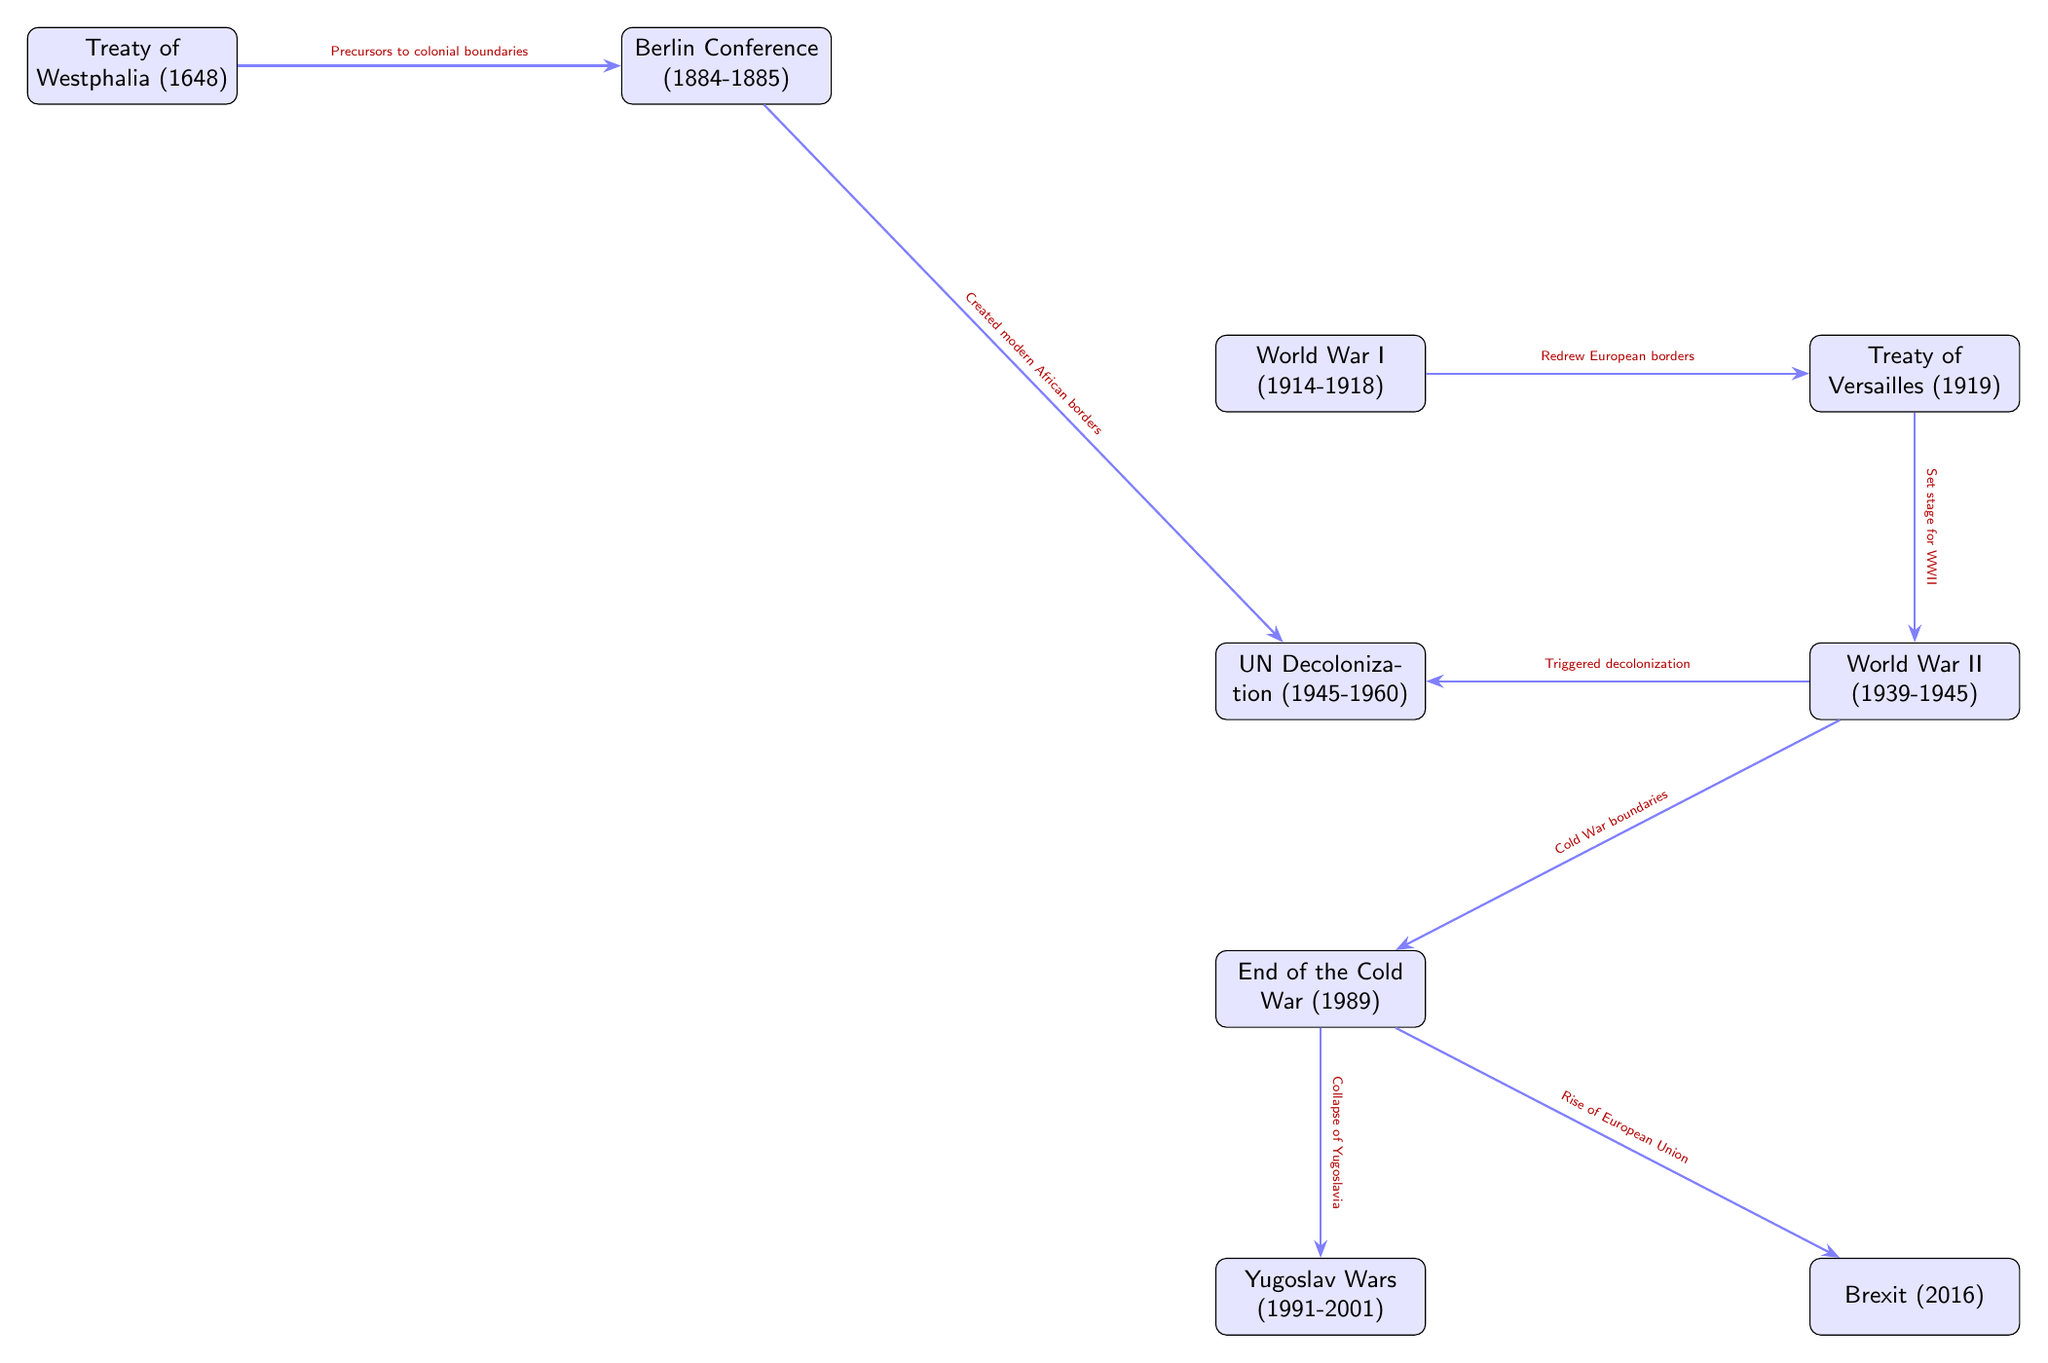What historical event is linked to the creation of modern African borders? The diagram shows an arrow from the Berlin Conference to UN Decolonization, indicating that the Berlin Conference is responsible for the creation of modern African borders.
Answer: Berlin Conference How many events are depicted in the diagram? By counting the nodes labeled with events in the diagram, there are a total of eight historical events presented.
Answer: 8 Which event triggered decolonization? The diagram shows an arrow pointing from World War II to UN Decolonization, indicating that World War II triggered the process of decolonization.
Answer: World War II What event is directly connected to the end of the Cold War? Looking at the diagram, there is an arrow from the End of the Cold War leading to both the Yugoslav Wars and the Rise of the European Union, indicating these events are directly influenced by the Cold War’s end.
Answer: End of the Cold War What does the Treaty of Versailles relate to? The diagram shows that the Treaty of Versailles is connected to the redrawing of European borders after World War I, as indicated by the arrow leading from World War I to the Treaty of Versailles.
Answer: Redrew European borders What event precedes the creation of modern African borders? The arrow from the Treaty of Westphalia points to the Berlin Conference, indicating that the Treaty of Westphalia is the precursor to the creation of modern African borders through the Berlin Conference.
Answer: Treaty of Westphalia Which two historical events suggest the creation of new political regions in Europe? The diagram shows that the End of the Cold War leads to both the Collapse of Yugoslavia and the Rise of the European Union, indicating the emergence of new political regions in Europe.
Answer: End of the Cold War Which event set the stage for World War II? The diagram indicates a direct relationship between the Treaty of Versailles and World War II, suggesting that the Treaty of Versailles set the stage for World War II.
Answer: Treaty of Versailles 